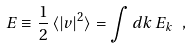Convert formula to latex. <formula><loc_0><loc_0><loc_500><loc_500>E \equiv \frac { 1 } { 2 } \, \langle | v | ^ { 2 } \rangle = \int d k \, E _ { k } \ ,</formula> 